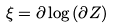Convert formula to latex. <formula><loc_0><loc_0><loc_500><loc_500>\xi = \partial \log { ( \partial Z ) }</formula> 